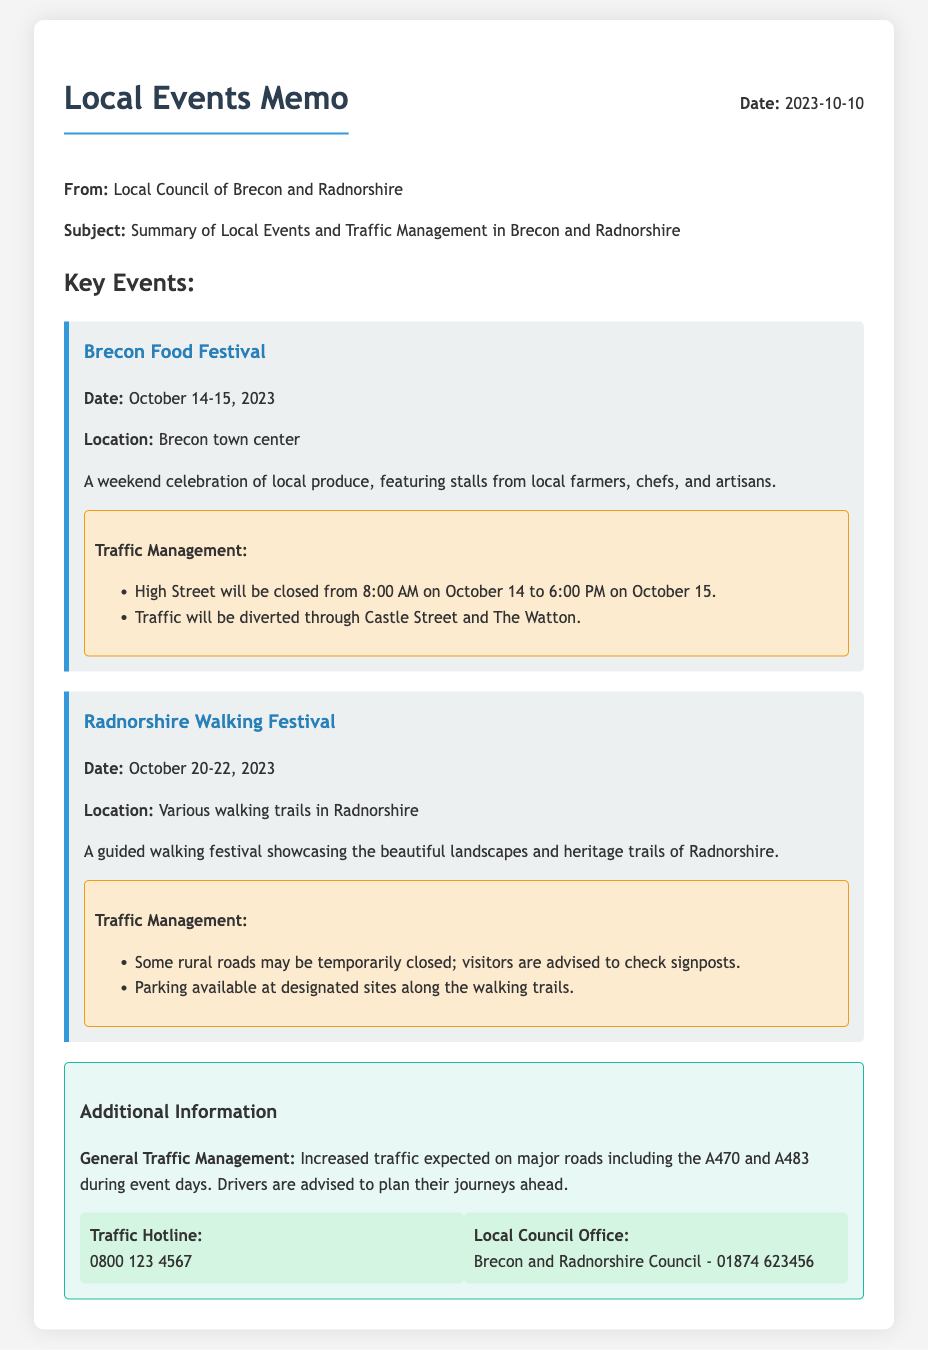What is the date of the Brecon Food Festival? The date is mentioned in the event section for the Brecon Food Festival, which is October 14-15, 2023.
Answer: October 14-15, 2023 What is the traffic management plan for the Brecon Food Festival? The traffic management section specifies the closure of High Street and the diversion through Castle Street and The Watton.
Answer: High Street closed; diverted through Castle Street and The Watton What locations are participants advised to check during the Radnorshire Walking Festival? The document mentions that visitors should check signposts for information regarding some rural roads that may be temporarily closed.
Answer: Signposts How many years has the Radnorshire Walking Festival been held? The document does not specify the number of years; only the date for this year's event is mentioned.
Answer: Not specified What is the contact number for the Traffic Hotline? The contact information section provides the specific number for the Traffic Hotline as 0800 123 4567.
Answer: 0800 123 4567 How will traffic affect major roads during events? The additional information outlines that increased traffic is expected on major roads during event days, advising drivers to plan ahead.
Answer: Increased traffic expected Where will parking be available during the Radnorshire Walking Festival? The traffic management plan indicates that parking is available at designated sites along the walking trails.
Answer: Designated sites along the walking trails What is the document's purpose? The memo's subject clearly states that it summarizes local events and traffic management in Brecon and Radnorshire.
Answer: Summary of Local Events and Traffic Management When does the memo indicate that increased traffic will occur? The memo mentions that increased traffic is expected during event days, highlighting specific days associated with events.
Answer: During event days 